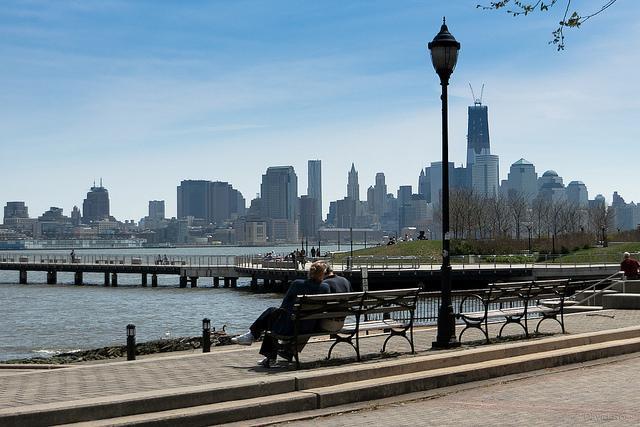How many benches are there?
Give a very brief answer. 2. How many benches are visible?
Give a very brief answer. 2. 